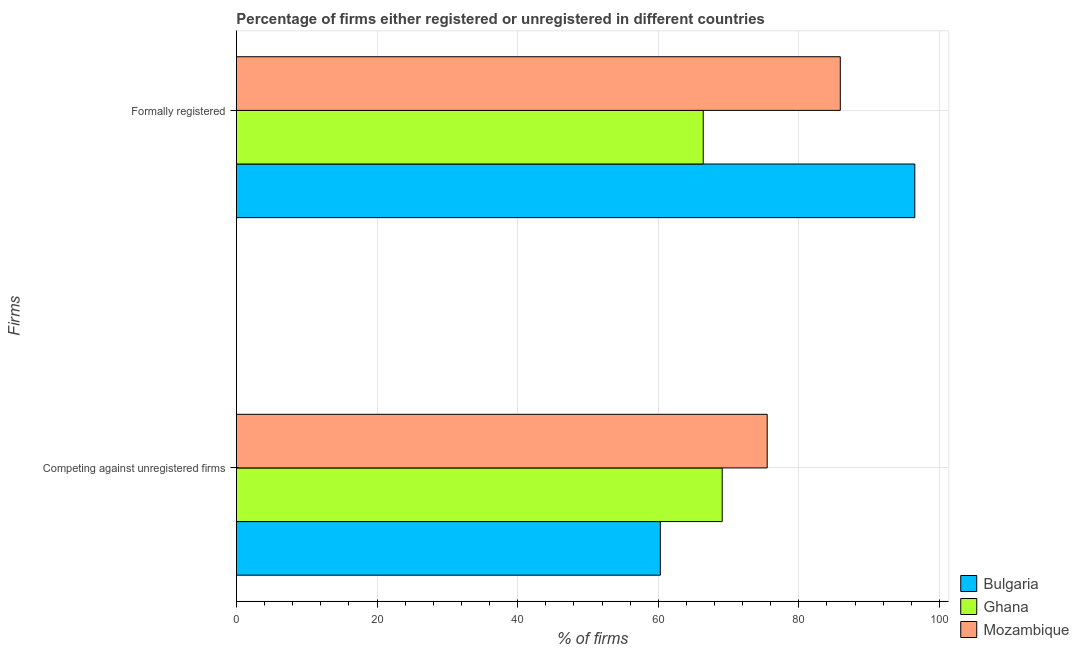How many different coloured bars are there?
Provide a short and direct response. 3. Are the number of bars on each tick of the Y-axis equal?
Your answer should be compact. Yes. How many bars are there on the 2nd tick from the top?
Provide a succinct answer. 3. What is the label of the 1st group of bars from the top?
Offer a terse response. Formally registered. What is the percentage of formally registered firms in Bulgaria?
Your response must be concise. 96.5. Across all countries, what is the maximum percentage of registered firms?
Ensure brevity in your answer.  75.5. Across all countries, what is the minimum percentage of registered firms?
Provide a succinct answer. 60.3. In which country was the percentage of registered firms maximum?
Your answer should be compact. Mozambique. In which country was the percentage of registered firms minimum?
Offer a very short reply. Bulgaria. What is the total percentage of registered firms in the graph?
Provide a succinct answer. 204.9. What is the difference between the percentage of registered firms in Ghana and that in Bulgaria?
Make the answer very short. 8.8. What is the difference between the percentage of registered firms in Bulgaria and the percentage of formally registered firms in Ghana?
Your answer should be compact. -6.1. What is the average percentage of registered firms per country?
Your answer should be very brief. 68.3. What is the difference between the percentage of registered firms and percentage of formally registered firms in Ghana?
Provide a succinct answer. 2.7. What is the ratio of the percentage of formally registered firms in Bulgaria to that in Mozambique?
Ensure brevity in your answer.  1.12. Is the percentage of registered firms in Ghana less than that in Mozambique?
Your answer should be compact. Yes. What does the 1st bar from the top in Competing against unregistered firms represents?
Ensure brevity in your answer.  Mozambique. What does the 1st bar from the bottom in Formally registered represents?
Ensure brevity in your answer.  Bulgaria. How many bars are there?
Your response must be concise. 6. Are all the bars in the graph horizontal?
Ensure brevity in your answer.  Yes. Are the values on the major ticks of X-axis written in scientific E-notation?
Your answer should be compact. No. How are the legend labels stacked?
Ensure brevity in your answer.  Vertical. What is the title of the graph?
Offer a very short reply. Percentage of firms either registered or unregistered in different countries. Does "Albania" appear as one of the legend labels in the graph?
Give a very brief answer. No. What is the label or title of the X-axis?
Your answer should be very brief. % of firms. What is the label or title of the Y-axis?
Provide a succinct answer. Firms. What is the % of firms in Bulgaria in Competing against unregistered firms?
Ensure brevity in your answer.  60.3. What is the % of firms in Ghana in Competing against unregistered firms?
Keep it short and to the point. 69.1. What is the % of firms in Mozambique in Competing against unregistered firms?
Offer a very short reply. 75.5. What is the % of firms of Bulgaria in Formally registered?
Provide a succinct answer. 96.5. What is the % of firms in Ghana in Formally registered?
Ensure brevity in your answer.  66.4. What is the % of firms of Mozambique in Formally registered?
Your answer should be very brief. 85.9. Across all Firms, what is the maximum % of firms in Bulgaria?
Ensure brevity in your answer.  96.5. Across all Firms, what is the maximum % of firms of Ghana?
Your response must be concise. 69.1. Across all Firms, what is the maximum % of firms of Mozambique?
Provide a succinct answer. 85.9. Across all Firms, what is the minimum % of firms of Bulgaria?
Keep it short and to the point. 60.3. Across all Firms, what is the minimum % of firms of Ghana?
Give a very brief answer. 66.4. Across all Firms, what is the minimum % of firms of Mozambique?
Offer a very short reply. 75.5. What is the total % of firms of Bulgaria in the graph?
Make the answer very short. 156.8. What is the total % of firms in Ghana in the graph?
Your answer should be very brief. 135.5. What is the total % of firms of Mozambique in the graph?
Your response must be concise. 161.4. What is the difference between the % of firms in Bulgaria in Competing against unregistered firms and that in Formally registered?
Your answer should be very brief. -36.2. What is the difference between the % of firms of Ghana in Competing against unregistered firms and that in Formally registered?
Your answer should be compact. 2.7. What is the difference between the % of firms in Mozambique in Competing against unregistered firms and that in Formally registered?
Keep it short and to the point. -10.4. What is the difference between the % of firms of Bulgaria in Competing against unregistered firms and the % of firms of Mozambique in Formally registered?
Make the answer very short. -25.6. What is the difference between the % of firms in Ghana in Competing against unregistered firms and the % of firms in Mozambique in Formally registered?
Make the answer very short. -16.8. What is the average % of firms in Bulgaria per Firms?
Offer a terse response. 78.4. What is the average % of firms of Ghana per Firms?
Your answer should be compact. 67.75. What is the average % of firms in Mozambique per Firms?
Keep it short and to the point. 80.7. What is the difference between the % of firms of Bulgaria and % of firms of Ghana in Competing against unregistered firms?
Make the answer very short. -8.8. What is the difference between the % of firms of Bulgaria and % of firms of Mozambique in Competing against unregistered firms?
Provide a succinct answer. -15.2. What is the difference between the % of firms of Ghana and % of firms of Mozambique in Competing against unregistered firms?
Your answer should be very brief. -6.4. What is the difference between the % of firms of Bulgaria and % of firms of Ghana in Formally registered?
Offer a terse response. 30.1. What is the difference between the % of firms of Bulgaria and % of firms of Mozambique in Formally registered?
Provide a succinct answer. 10.6. What is the difference between the % of firms in Ghana and % of firms in Mozambique in Formally registered?
Keep it short and to the point. -19.5. What is the ratio of the % of firms in Bulgaria in Competing against unregistered firms to that in Formally registered?
Make the answer very short. 0.62. What is the ratio of the % of firms of Ghana in Competing against unregistered firms to that in Formally registered?
Offer a very short reply. 1.04. What is the ratio of the % of firms of Mozambique in Competing against unregistered firms to that in Formally registered?
Provide a succinct answer. 0.88. What is the difference between the highest and the second highest % of firms of Bulgaria?
Provide a succinct answer. 36.2. What is the difference between the highest and the second highest % of firms of Ghana?
Provide a short and direct response. 2.7. What is the difference between the highest and the second highest % of firms of Mozambique?
Provide a succinct answer. 10.4. What is the difference between the highest and the lowest % of firms in Bulgaria?
Give a very brief answer. 36.2. What is the difference between the highest and the lowest % of firms in Mozambique?
Make the answer very short. 10.4. 